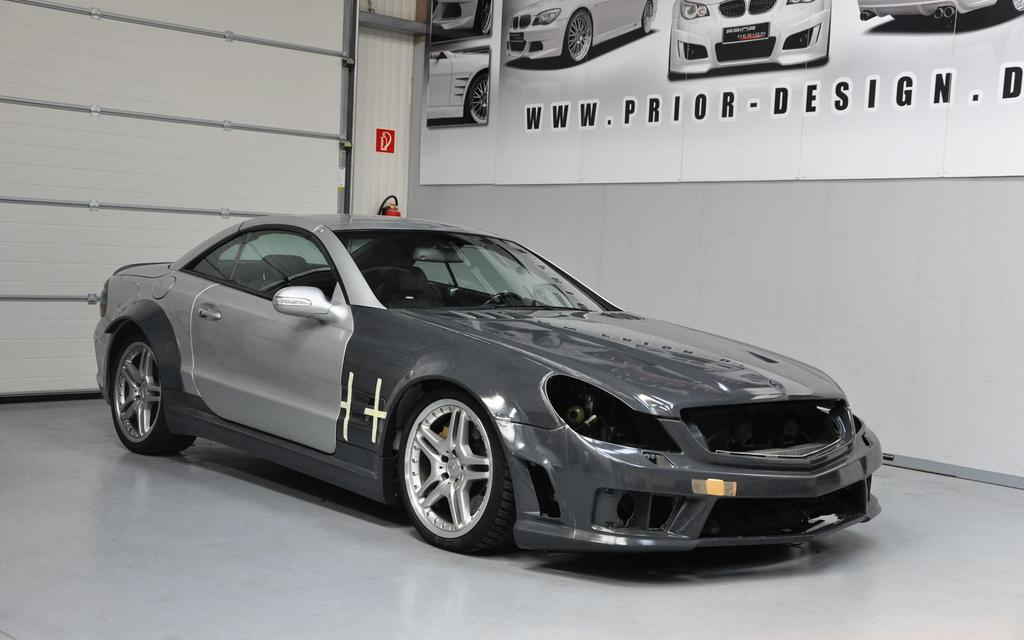What is the main subject of the image? The main subject of the image is a car. Can you describe the car's appearance? The car is grey in color. What else can be seen in the image besides the car? There is a banner on the wall in the right side of the image. Is there a cap on the car's roof in the image? There is no cap visible on the car's roof in the image. What type of crack can be seen on the car's windshield in the image? There is no crack visible on the car's windshield in the image. 